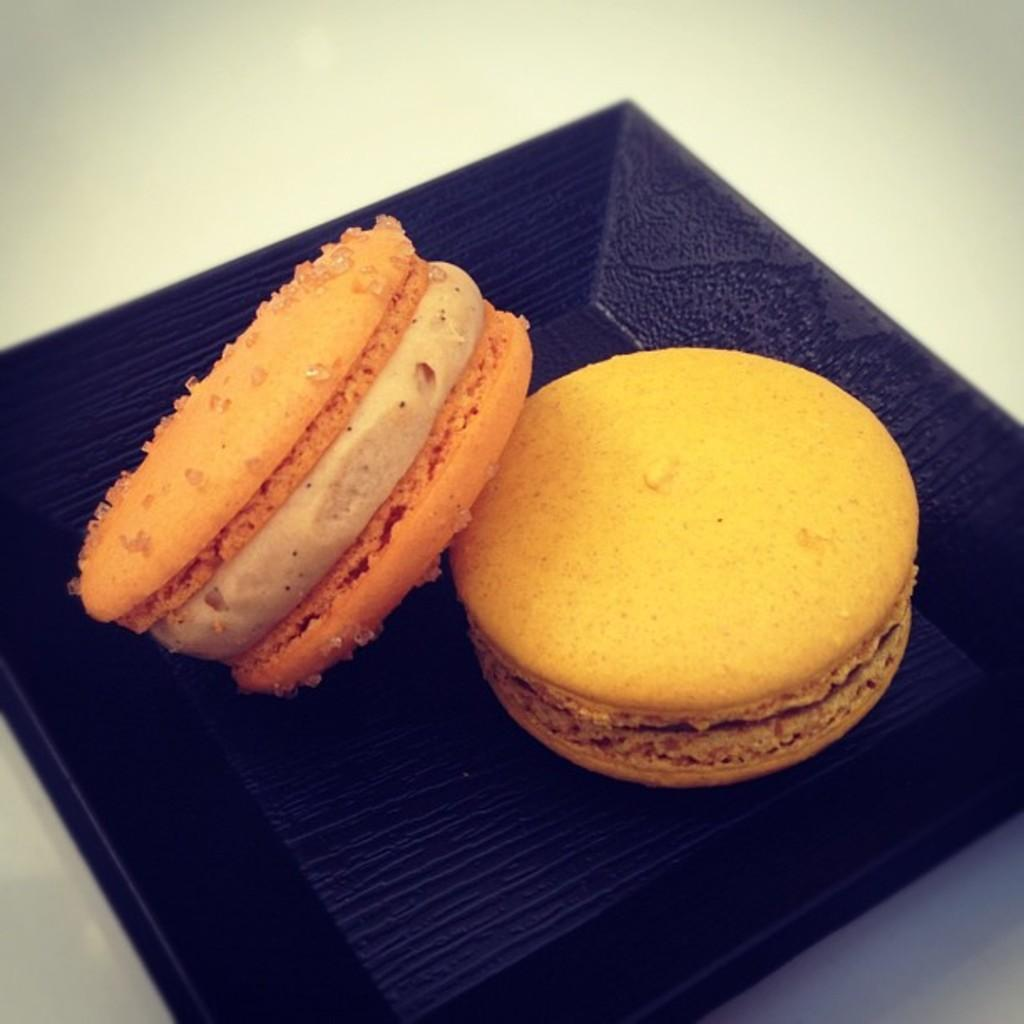What type of food is visible in the image? There are macarons in the image. How are the macarons presented? The macarons are served on a plate. Where is the plate with macarons located? The plate is placed on a table. What type of lumber is being used to construct the table in the image? There is no information about the table's construction in the image, so it cannot be determined what type of lumber is being used. 